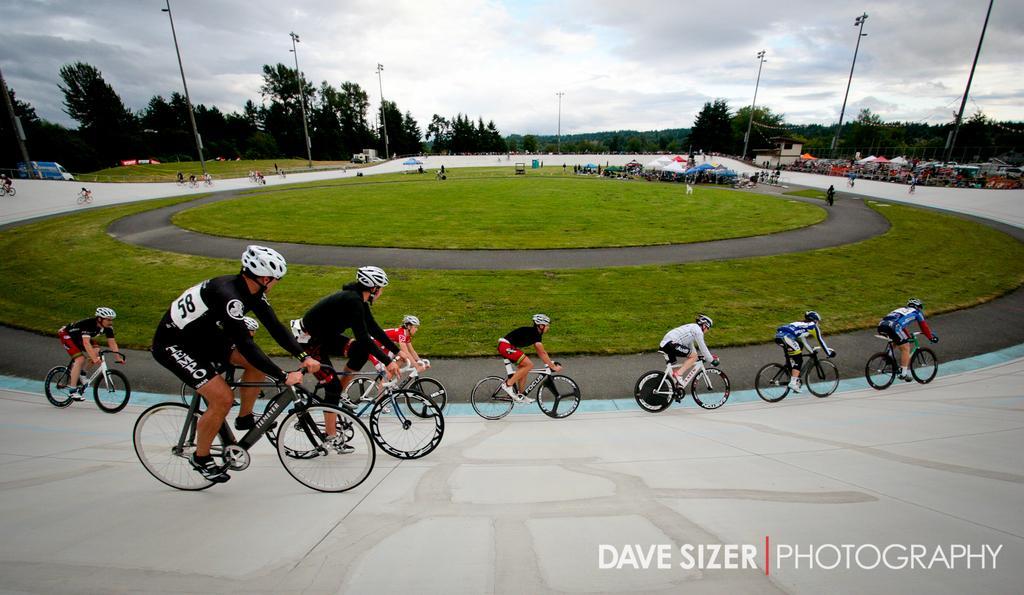In one or two sentences, can you explain what this image depicts? In this image, we can see people wearing sports dress and helmets and are riding bicycles. In the background, there are trees, poles, lights, sheds, vehicles, a fence and there is a crowd. At the top, there are clouds in the sky and at the bottom, there is ground and we can see some text. 